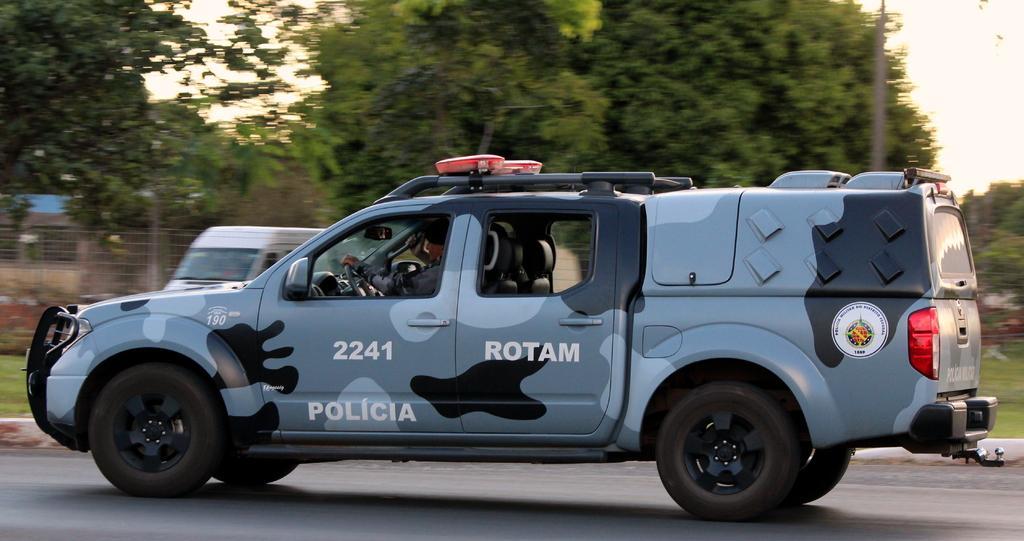How would you summarize this image in a sentence or two? This is an outside view. Here I can see two vehicles on the road. In the background there are many trees. On the left side there is a railing. At the top of the image I can see the sky. Here I can see a person inside the vehicle. 